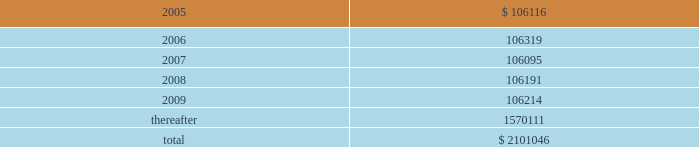American tower corporation and subsidiaries notes to consolidated financial statements 2014 ( continued ) 7 .
Derivative financial instruments under the terms of the credit facility , the company is required to enter into interest rate protection agreements on at least 50% ( 50 % ) of its variable rate debt .
Under these agreements , the company is exposed to credit risk to the extent that a counterparty fails to meet the terms of a contract .
Such exposure is limited to the current value of the contract at the time the counterparty fails to perform .
The company believes its contracts as of december 31 , 2004 are with credit worthy institutions .
As of december 31 , 2004 , the company had two interest rate caps outstanding with an aggregate notional amount of $ 350.0 million ( each at an interest rate of 6.0% ( 6.0 % ) ) that expire in 2006 .
As of december 31 , 2003 , the company had three interest rate caps outstanding with an aggregate notional amount of $ 500.0 million ( each at a rate of 5.0% ( 5.0 % ) ) that expired in 2004 .
As of december 31 , 2004 and 2003 , there was no fair value associated with any of these interest rate caps .
During the year ended december 31 , 2003 , the company recorded an unrealized loss of approximately $ 0.3 million ( net of a tax benefit of approximately $ 0.2 million ) in other comprehensive loss for the change in fair value of cash flow hedges and reclassified $ 5.9 million ( net of a tax benefit of approximately $ 3.2 million ) into results of operations .
During the year ended december 31 , 2002 , the company recorded an unrealized loss of approximately $ 9.1 million ( net of a tax benefit of approximately $ 4.9 million ) in other comprehensive loss for the change in fair value of cash flow hedges and reclassified $ 19.5 million ( net of a tax benefit of approximately $ 10.5 million ) into results of operations .
Hedge ineffectiveness resulted in a gain of approximately $ 1.0 million for the year ended december 31 , 2002 , which is recorded in other expense in the accompanying consolidated statement of operations .
The company records the changes in fair value of its derivative instruments that are not accounted for as hedges in other expense .
The company did not reclassify any derivative losses into its statement of operations for the year ended december 31 , 2004 and does not anticipate reclassifying any derivative losses into its statement of operations within the next twelve months , as there are no amounts included in other comprehensive loss as of december 31 , 2004 .
Commitments and contingencies lease obligations 2014the company leases certain land , office and tower space under operating leases that expire over various terms .
Many of the leases contain renewal options with specified increases in lease payments upon exercise of the renewal option .
Escalation clauses present in operating leases , excluding those tied to cpi or other inflation-based indices , are straight-lined over the term of the lease .
( see note 1. ) future minimum rental payments under non-cancelable operating leases include payments for certain renewal periods at the company 2019s option because failure to renew could result in a loss of the applicable tower site and related revenues from tenant leases , thereby making it reasonably assured that the company will renew the lease .
Such payments in effect at december 31 , 2004 are as follows ( in thousands ) : year ending december 31 .
Aggregate rent expense ( including the effect of straight-line rent expense ) under operating leases for the years ended december 31 , 2004 , 2003 and 2002 approximated $ 118741000 , $ 113956000 , and $ 109644000 , respectively. .
What is the percentage change in aggregate rent expense from 2002 to 2003? 
Computations: ((113956000 - 109644000) / 109644000)
Answer: 0.03933. 